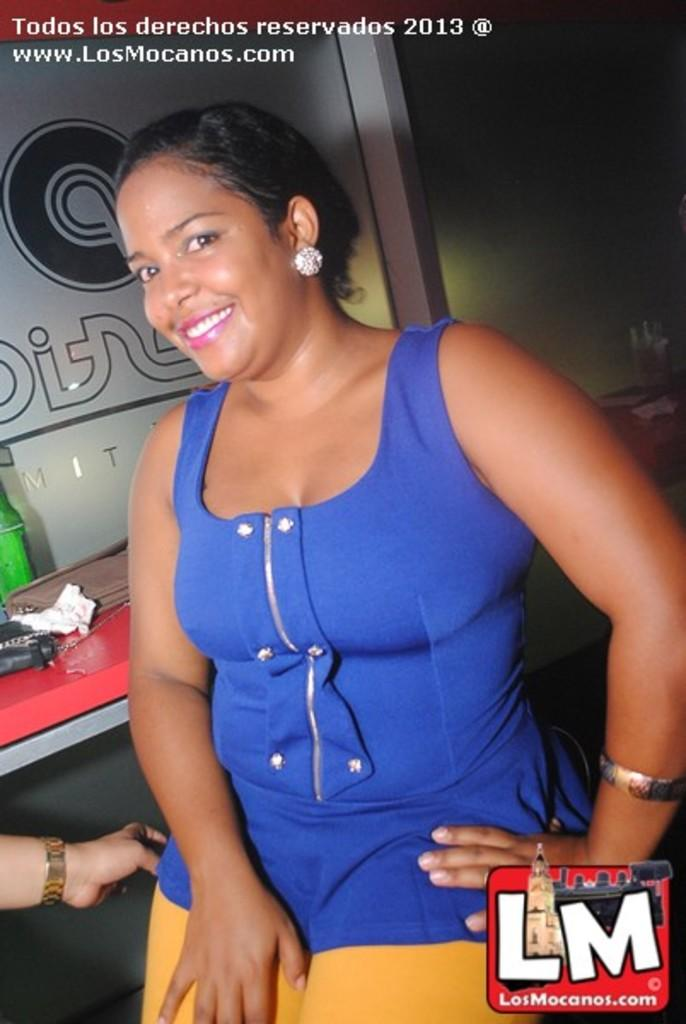<image>
Describe the image concisely. An advertisement with a woman in a blue top for the website losmocanos.com 